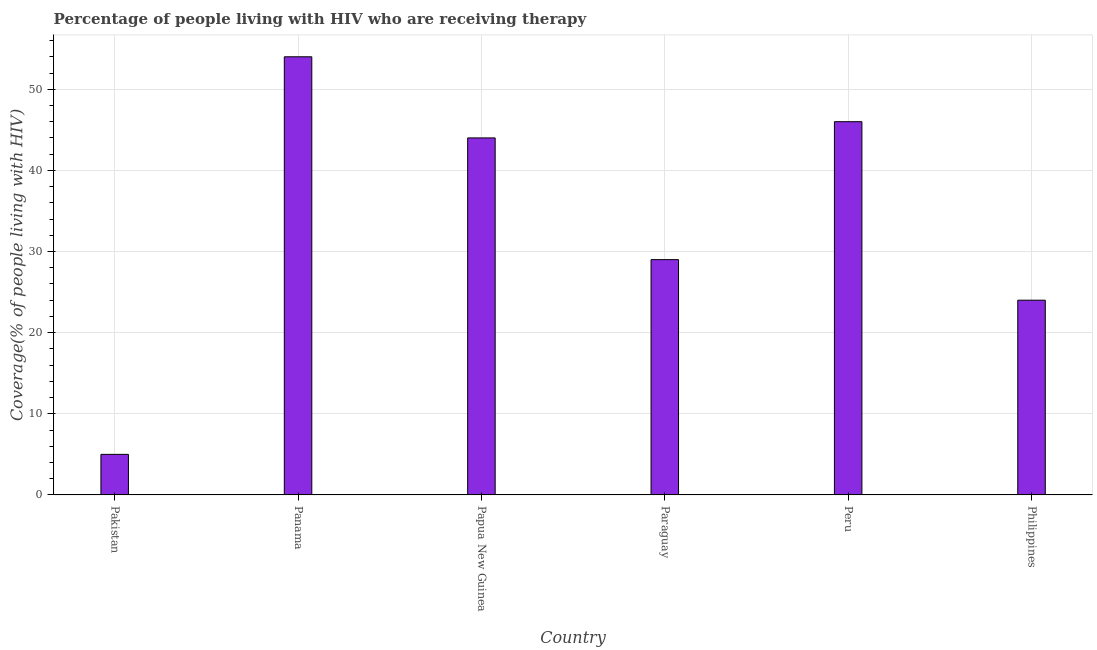What is the title of the graph?
Keep it short and to the point. Percentage of people living with HIV who are receiving therapy. What is the label or title of the X-axis?
Your response must be concise. Country. What is the label or title of the Y-axis?
Your response must be concise. Coverage(% of people living with HIV). What is the antiretroviral therapy coverage in Panama?
Make the answer very short. 54. Across all countries, what is the maximum antiretroviral therapy coverage?
Provide a succinct answer. 54. In which country was the antiretroviral therapy coverage maximum?
Offer a terse response. Panama. What is the sum of the antiretroviral therapy coverage?
Give a very brief answer. 202. What is the difference between the antiretroviral therapy coverage in Pakistan and Panama?
Provide a succinct answer. -49. What is the average antiretroviral therapy coverage per country?
Keep it short and to the point. 33.67. What is the median antiretroviral therapy coverage?
Your answer should be compact. 36.5. In how many countries, is the antiretroviral therapy coverage greater than 2 %?
Ensure brevity in your answer.  6. What is the ratio of the antiretroviral therapy coverage in Papua New Guinea to that in Philippines?
Make the answer very short. 1.83. What is the difference between the highest and the second highest antiretroviral therapy coverage?
Your response must be concise. 8. Is the sum of the antiretroviral therapy coverage in Pakistan and Peru greater than the maximum antiretroviral therapy coverage across all countries?
Offer a very short reply. No. How many bars are there?
Your response must be concise. 6. Are all the bars in the graph horizontal?
Give a very brief answer. No. Are the values on the major ticks of Y-axis written in scientific E-notation?
Your response must be concise. No. What is the Coverage(% of people living with HIV) in Panama?
Offer a terse response. 54. What is the Coverage(% of people living with HIV) in Paraguay?
Your answer should be very brief. 29. What is the Coverage(% of people living with HIV) in Peru?
Your response must be concise. 46. What is the Coverage(% of people living with HIV) in Philippines?
Offer a terse response. 24. What is the difference between the Coverage(% of people living with HIV) in Pakistan and Panama?
Provide a short and direct response. -49. What is the difference between the Coverage(% of people living with HIV) in Pakistan and Papua New Guinea?
Your answer should be compact. -39. What is the difference between the Coverage(% of people living with HIV) in Pakistan and Peru?
Your response must be concise. -41. What is the difference between the Coverage(% of people living with HIV) in Panama and Peru?
Offer a terse response. 8. What is the difference between the Coverage(% of people living with HIV) in Papua New Guinea and Peru?
Your answer should be compact. -2. What is the difference between the Coverage(% of people living with HIV) in Papua New Guinea and Philippines?
Provide a succinct answer. 20. What is the difference between the Coverage(% of people living with HIV) in Peru and Philippines?
Offer a terse response. 22. What is the ratio of the Coverage(% of people living with HIV) in Pakistan to that in Panama?
Your answer should be very brief. 0.09. What is the ratio of the Coverage(% of people living with HIV) in Pakistan to that in Papua New Guinea?
Give a very brief answer. 0.11. What is the ratio of the Coverage(% of people living with HIV) in Pakistan to that in Paraguay?
Offer a terse response. 0.17. What is the ratio of the Coverage(% of people living with HIV) in Pakistan to that in Peru?
Give a very brief answer. 0.11. What is the ratio of the Coverage(% of people living with HIV) in Pakistan to that in Philippines?
Offer a terse response. 0.21. What is the ratio of the Coverage(% of people living with HIV) in Panama to that in Papua New Guinea?
Give a very brief answer. 1.23. What is the ratio of the Coverage(% of people living with HIV) in Panama to that in Paraguay?
Your answer should be compact. 1.86. What is the ratio of the Coverage(% of people living with HIV) in Panama to that in Peru?
Provide a succinct answer. 1.17. What is the ratio of the Coverage(% of people living with HIV) in Panama to that in Philippines?
Provide a succinct answer. 2.25. What is the ratio of the Coverage(% of people living with HIV) in Papua New Guinea to that in Paraguay?
Give a very brief answer. 1.52. What is the ratio of the Coverage(% of people living with HIV) in Papua New Guinea to that in Philippines?
Your answer should be compact. 1.83. What is the ratio of the Coverage(% of people living with HIV) in Paraguay to that in Peru?
Make the answer very short. 0.63. What is the ratio of the Coverage(% of people living with HIV) in Paraguay to that in Philippines?
Provide a succinct answer. 1.21. What is the ratio of the Coverage(% of people living with HIV) in Peru to that in Philippines?
Ensure brevity in your answer.  1.92. 